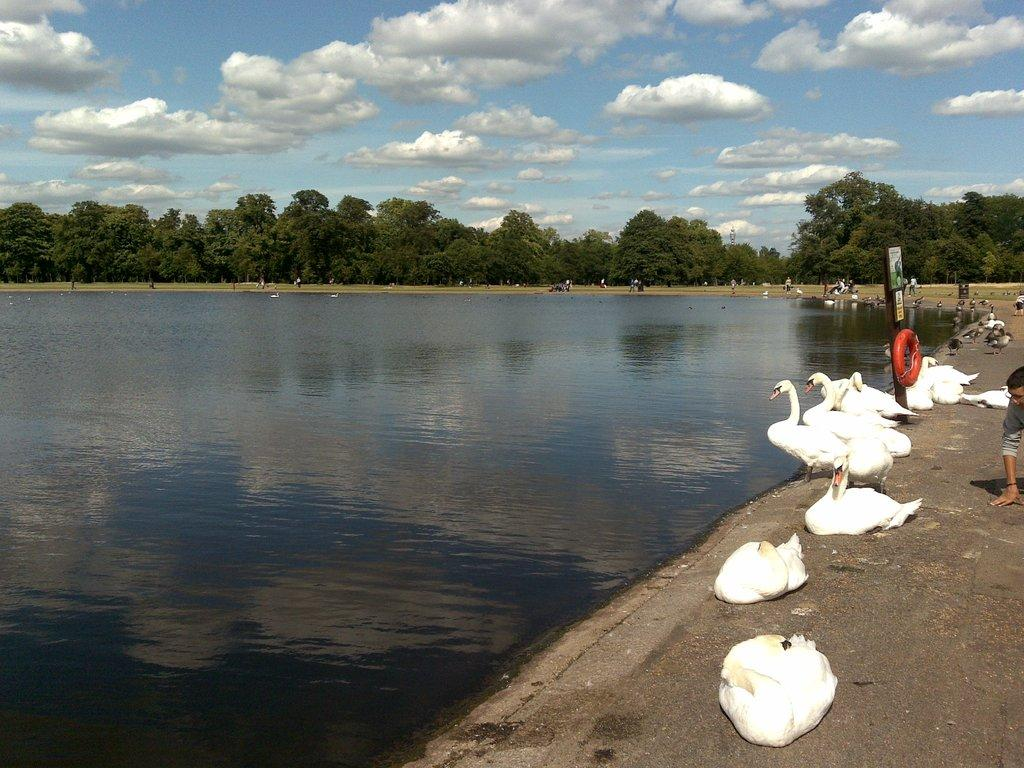What is the main feature in the center of the image? There is a lake in the center of the image. What can be seen on the right side of the image? There are swans and a board on the right side of the image. Can you describe the person in the image? There is a person in the image, but their specific appearance or actions are not mentioned in the facts. What type of vegetation is visible in the background of the image? There are trees in the background of the image. What else is visible in the background of the image? The sky is visible in the background of the image. What type of pen is the person using to write in the image? There is no pen or writing activity present in the image. What type of drink is the person holding in the image? There is no drink or person holding a drink present in the image. 